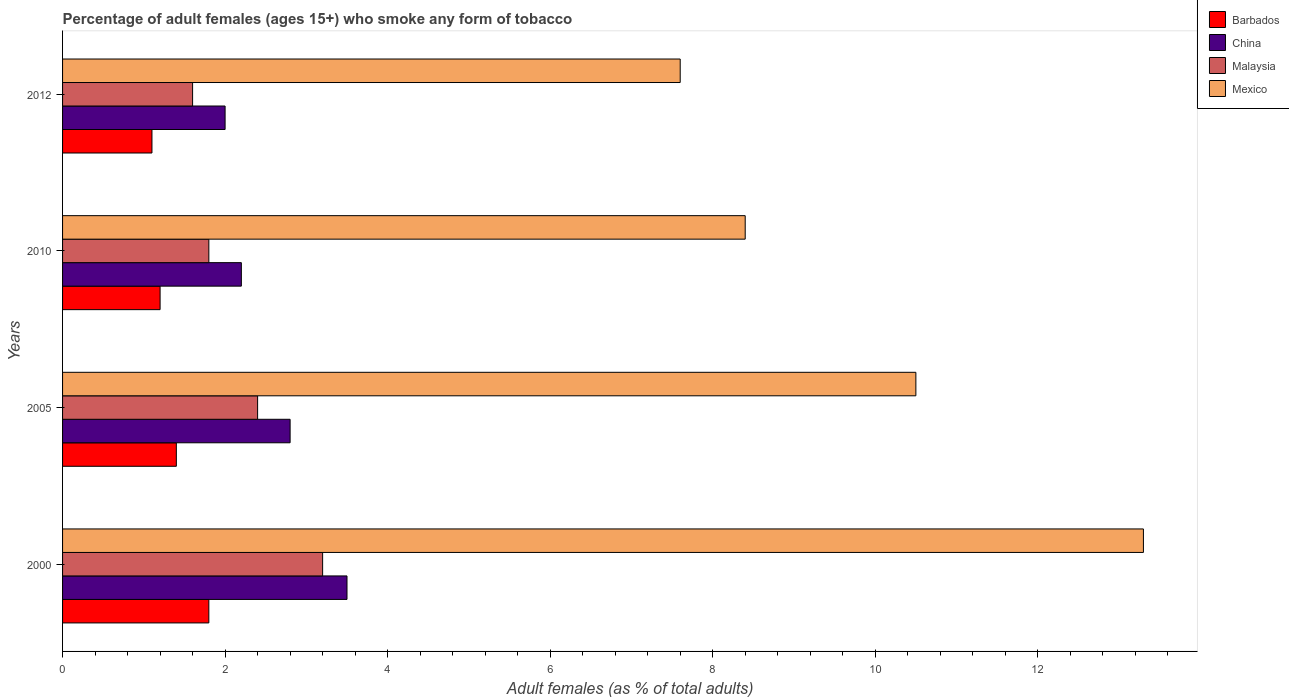Are the number of bars per tick equal to the number of legend labels?
Ensure brevity in your answer.  Yes. Are the number of bars on each tick of the Y-axis equal?
Provide a short and direct response. Yes. How many bars are there on the 4th tick from the top?
Offer a very short reply. 4. How many bars are there on the 3rd tick from the bottom?
Make the answer very short. 4. What is the label of the 1st group of bars from the top?
Offer a terse response. 2012. What is the percentage of adult females who smoke in China in 2005?
Your response must be concise. 2.8. Across all years, what is the maximum percentage of adult females who smoke in Malaysia?
Your response must be concise. 3.2. Across all years, what is the minimum percentage of adult females who smoke in Mexico?
Provide a succinct answer. 7.6. In which year was the percentage of adult females who smoke in Mexico maximum?
Give a very brief answer. 2000. What is the difference between the percentage of adult females who smoke in China in 2000 and that in 2005?
Give a very brief answer. 0.7. What is the difference between the percentage of adult females who smoke in Barbados in 2010 and the percentage of adult females who smoke in Malaysia in 2000?
Offer a very short reply. -2. What is the average percentage of adult females who smoke in China per year?
Ensure brevity in your answer.  2.62. What is the ratio of the percentage of adult females who smoke in Barbados in 2010 to that in 2012?
Give a very brief answer. 1.09. What is the difference between the highest and the second highest percentage of adult females who smoke in Barbados?
Offer a very short reply. 0.4. What is the difference between the highest and the lowest percentage of adult females who smoke in Barbados?
Your answer should be very brief. 0.7. In how many years, is the percentage of adult females who smoke in Mexico greater than the average percentage of adult females who smoke in Mexico taken over all years?
Ensure brevity in your answer.  2. Is the sum of the percentage of adult females who smoke in Mexico in 2000 and 2010 greater than the maximum percentage of adult females who smoke in Barbados across all years?
Provide a succinct answer. Yes. What does the 2nd bar from the top in 2000 represents?
Offer a very short reply. Malaysia. What does the 4th bar from the bottom in 2012 represents?
Provide a succinct answer. Mexico. How many bars are there?
Your answer should be very brief. 16. Are all the bars in the graph horizontal?
Provide a succinct answer. Yes. Are the values on the major ticks of X-axis written in scientific E-notation?
Keep it short and to the point. No. Does the graph contain grids?
Offer a very short reply. No. Where does the legend appear in the graph?
Your response must be concise. Top right. How are the legend labels stacked?
Keep it short and to the point. Vertical. What is the title of the graph?
Provide a succinct answer. Percentage of adult females (ages 15+) who smoke any form of tobacco. Does "Belarus" appear as one of the legend labels in the graph?
Give a very brief answer. No. What is the label or title of the X-axis?
Make the answer very short. Adult females (as % of total adults). What is the Adult females (as % of total adults) of Barbados in 2000?
Make the answer very short. 1.8. What is the Adult females (as % of total adults) in China in 2000?
Give a very brief answer. 3.5. What is the Adult females (as % of total adults) of Malaysia in 2000?
Provide a short and direct response. 3.2. What is the Adult females (as % of total adults) in Barbados in 2005?
Give a very brief answer. 1.4. What is the Adult females (as % of total adults) of Malaysia in 2005?
Your answer should be very brief. 2.4. What is the Adult females (as % of total adults) of China in 2012?
Make the answer very short. 2. What is the Adult females (as % of total adults) in Malaysia in 2012?
Your response must be concise. 1.6. Across all years, what is the maximum Adult females (as % of total adults) of Barbados?
Offer a very short reply. 1.8. Across all years, what is the maximum Adult females (as % of total adults) in China?
Offer a very short reply. 3.5. Across all years, what is the maximum Adult females (as % of total adults) of Malaysia?
Offer a very short reply. 3.2. Across all years, what is the maximum Adult females (as % of total adults) in Mexico?
Keep it short and to the point. 13.3. Across all years, what is the minimum Adult females (as % of total adults) of Barbados?
Offer a very short reply. 1.1. What is the total Adult females (as % of total adults) in Barbados in the graph?
Provide a short and direct response. 5.5. What is the total Adult females (as % of total adults) of Mexico in the graph?
Offer a very short reply. 39.8. What is the difference between the Adult females (as % of total adults) in Barbados in 2000 and that in 2005?
Provide a succinct answer. 0.4. What is the difference between the Adult females (as % of total adults) in Barbados in 2000 and that in 2010?
Your answer should be compact. 0.6. What is the difference between the Adult females (as % of total adults) of China in 2000 and that in 2010?
Keep it short and to the point. 1.3. What is the difference between the Adult females (as % of total adults) of China in 2000 and that in 2012?
Give a very brief answer. 1.5. What is the difference between the Adult females (as % of total adults) in Malaysia in 2005 and that in 2010?
Offer a very short reply. 0.6. What is the difference between the Adult females (as % of total adults) of Mexico in 2005 and that in 2010?
Offer a very short reply. 2.1. What is the difference between the Adult females (as % of total adults) of China in 2005 and that in 2012?
Offer a very short reply. 0.8. What is the difference between the Adult females (as % of total adults) in Malaysia in 2005 and that in 2012?
Keep it short and to the point. 0.8. What is the difference between the Adult females (as % of total adults) of China in 2010 and that in 2012?
Make the answer very short. 0.2. What is the difference between the Adult females (as % of total adults) of Malaysia in 2010 and that in 2012?
Offer a terse response. 0.2. What is the difference between the Adult females (as % of total adults) in Mexico in 2010 and that in 2012?
Keep it short and to the point. 0.8. What is the difference between the Adult females (as % of total adults) in Barbados in 2000 and the Adult females (as % of total adults) in Mexico in 2005?
Offer a terse response. -8.7. What is the difference between the Adult females (as % of total adults) of China in 2000 and the Adult females (as % of total adults) of Malaysia in 2005?
Make the answer very short. 1.1. What is the difference between the Adult females (as % of total adults) of China in 2000 and the Adult females (as % of total adults) of Mexico in 2005?
Provide a short and direct response. -7. What is the difference between the Adult females (as % of total adults) in Malaysia in 2000 and the Adult females (as % of total adults) in Mexico in 2005?
Your response must be concise. -7.3. What is the difference between the Adult females (as % of total adults) in Barbados in 2000 and the Adult females (as % of total adults) in China in 2010?
Offer a very short reply. -0.4. What is the difference between the Adult females (as % of total adults) of Barbados in 2000 and the Adult females (as % of total adults) of Mexico in 2010?
Your answer should be very brief. -6.6. What is the difference between the Adult females (as % of total adults) of China in 2000 and the Adult females (as % of total adults) of Malaysia in 2010?
Offer a very short reply. 1.7. What is the difference between the Adult females (as % of total adults) in China in 2000 and the Adult females (as % of total adults) in Mexico in 2010?
Your answer should be very brief. -4.9. What is the difference between the Adult females (as % of total adults) in Barbados in 2000 and the Adult females (as % of total adults) in China in 2012?
Your answer should be very brief. -0.2. What is the difference between the Adult females (as % of total adults) of Barbados in 2000 and the Adult females (as % of total adults) of Malaysia in 2012?
Offer a very short reply. 0.2. What is the difference between the Adult females (as % of total adults) of Barbados in 2000 and the Adult females (as % of total adults) of Mexico in 2012?
Ensure brevity in your answer.  -5.8. What is the difference between the Adult females (as % of total adults) of China in 2000 and the Adult females (as % of total adults) of Mexico in 2012?
Offer a terse response. -4.1. What is the difference between the Adult females (as % of total adults) of Malaysia in 2000 and the Adult females (as % of total adults) of Mexico in 2012?
Your response must be concise. -4.4. What is the difference between the Adult females (as % of total adults) of Barbados in 2005 and the Adult females (as % of total adults) of China in 2012?
Keep it short and to the point. -0.6. What is the difference between the Adult females (as % of total adults) in Barbados in 2005 and the Adult females (as % of total adults) in Malaysia in 2012?
Provide a succinct answer. -0.2. What is the difference between the Adult females (as % of total adults) of Barbados in 2005 and the Adult females (as % of total adults) of Mexico in 2012?
Ensure brevity in your answer.  -6.2. What is the difference between the Adult females (as % of total adults) of China in 2005 and the Adult females (as % of total adults) of Malaysia in 2012?
Give a very brief answer. 1.2. What is the difference between the Adult females (as % of total adults) of Barbados in 2010 and the Adult females (as % of total adults) of China in 2012?
Your response must be concise. -0.8. What is the difference between the Adult females (as % of total adults) of Barbados in 2010 and the Adult females (as % of total adults) of Malaysia in 2012?
Your answer should be compact. -0.4. What is the difference between the Adult females (as % of total adults) of China in 2010 and the Adult females (as % of total adults) of Malaysia in 2012?
Make the answer very short. 0.6. What is the difference between the Adult females (as % of total adults) of China in 2010 and the Adult females (as % of total adults) of Mexico in 2012?
Your answer should be compact. -5.4. What is the difference between the Adult females (as % of total adults) of Malaysia in 2010 and the Adult females (as % of total adults) of Mexico in 2012?
Give a very brief answer. -5.8. What is the average Adult females (as % of total adults) of Barbados per year?
Offer a terse response. 1.38. What is the average Adult females (as % of total adults) in China per year?
Make the answer very short. 2.62. What is the average Adult females (as % of total adults) in Malaysia per year?
Your answer should be very brief. 2.25. What is the average Adult females (as % of total adults) of Mexico per year?
Provide a succinct answer. 9.95. In the year 2000, what is the difference between the Adult females (as % of total adults) in Barbados and Adult females (as % of total adults) in China?
Provide a succinct answer. -1.7. In the year 2000, what is the difference between the Adult females (as % of total adults) in Malaysia and Adult females (as % of total adults) in Mexico?
Keep it short and to the point. -10.1. In the year 2005, what is the difference between the Adult females (as % of total adults) of Barbados and Adult females (as % of total adults) of China?
Your answer should be compact. -1.4. In the year 2005, what is the difference between the Adult females (as % of total adults) in Barbados and Adult females (as % of total adults) in Malaysia?
Keep it short and to the point. -1. In the year 2010, what is the difference between the Adult females (as % of total adults) of Barbados and Adult females (as % of total adults) of China?
Offer a terse response. -1. In the year 2010, what is the difference between the Adult females (as % of total adults) in Barbados and Adult females (as % of total adults) in Malaysia?
Offer a very short reply. -0.6. In the year 2010, what is the difference between the Adult females (as % of total adults) in Malaysia and Adult females (as % of total adults) in Mexico?
Provide a short and direct response. -6.6. In the year 2012, what is the difference between the Adult females (as % of total adults) in Barbados and Adult females (as % of total adults) in Mexico?
Give a very brief answer. -6.5. In the year 2012, what is the difference between the Adult females (as % of total adults) in China and Adult females (as % of total adults) in Mexico?
Offer a very short reply. -5.6. In the year 2012, what is the difference between the Adult females (as % of total adults) in Malaysia and Adult females (as % of total adults) in Mexico?
Your answer should be very brief. -6. What is the ratio of the Adult females (as % of total adults) in China in 2000 to that in 2005?
Make the answer very short. 1.25. What is the ratio of the Adult females (as % of total adults) in Malaysia in 2000 to that in 2005?
Your answer should be very brief. 1.33. What is the ratio of the Adult females (as % of total adults) of Mexico in 2000 to that in 2005?
Offer a very short reply. 1.27. What is the ratio of the Adult females (as % of total adults) in China in 2000 to that in 2010?
Provide a short and direct response. 1.59. What is the ratio of the Adult females (as % of total adults) of Malaysia in 2000 to that in 2010?
Your response must be concise. 1.78. What is the ratio of the Adult females (as % of total adults) in Mexico in 2000 to that in 2010?
Give a very brief answer. 1.58. What is the ratio of the Adult females (as % of total adults) of Barbados in 2000 to that in 2012?
Make the answer very short. 1.64. What is the ratio of the Adult females (as % of total adults) in China in 2000 to that in 2012?
Provide a succinct answer. 1.75. What is the ratio of the Adult females (as % of total adults) of Malaysia in 2000 to that in 2012?
Ensure brevity in your answer.  2. What is the ratio of the Adult females (as % of total adults) of China in 2005 to that in 2010?
Ensure brevity in your answer.  1.27. What is the ratio of the Adult females (as % of total adults) in Barbados in 2005 to that in 2012?
Give a very brief answer. 1.27. What is the ratio of the Adult females (as % of total adults) in Malaysia in 2005 to that in 2012?
Make the answer very short. 1.5. What is the ratio of the Adult females (as % of total adults) in Mexico in 2005 to that in 2012?
Make the answer very short. 1.38. What is the ratio of the Adult females (as % of total adults) in Malaysia in 2010 to that in 2012?
Give a very brief answer. 1.12. What is the ratio of the Adult females (as % of total adults) in Mexico in 2010 to that in 2012?
Your answer should be compact. 1.11. What is the difference between the highest and the second highest Adult females (as % of total adults) of Barbados?
Make the answer very short. 0.4. What is the difference between the highest and the second highest Adult females (as % of total adults) of Mexico?
Your answer should be very brief. 2.8. What is the difference between the highest and the lowest Adult females (as % of total adults) in Barbados?
Provide a short and direct response. 0.7. 